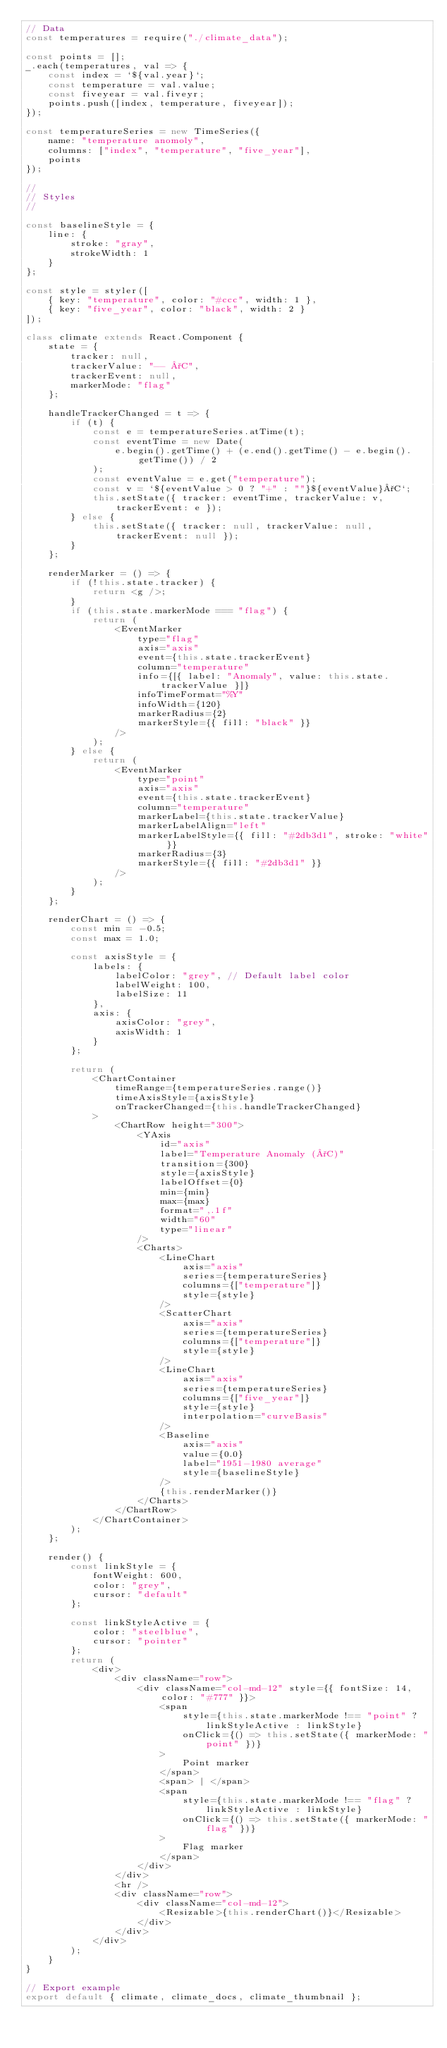Convert code to text. <code><loc_0><loc_0><loc_500><loc_500><_JavaScript_>// Data
const temperatures = require("./climate_data");

const points = [];
_.each(temperatures, val => {
    const index = `${val.year}`;
    const temperature = val.value;
    const fiveyear = val.fiveyr;
    points.push([index, temperature, fiveyear]);
});

const temperatureSeries = new TimeSeries({
    name: "temperature anomoly",
    columns: ["index", "temperature", "five_year"],
    points
});

//
// Styles
//

const baselineStyle = {
    line: {
        stroke: "gray",
        strokeWidth: 1
    }
};

const style = styler([
    { key: "temperature", color: "#ccc", width: 1 },
    { key: "five_year", color: "black", width: 2 }
]);

class climate extends React.Component {
    state = {
        tracker: null,
        trackerValue: "-- °C",
        trackerEvent: null,
        markerMode: "flag"
    };

    handleTrackerChanged = t => {
        if (t) {
            const e = temperatureSeries.atTime(t);
            const eventTime = new Date(
                e.begin().getTime() + (e.end().getTime() - e.begin().getTime()) / 2
            );
            const eventValue = e.get("temperature");
            const v = `${eventValue > 0 ? "+" : ""}${eventValue}°C`;
            this.setState({ tracker: eventTime, trackerValue: v, trackerEvent: e });
        } else {
            this.setState({ tracker: null, trackerValue: null, trackerEvent: null });
        }
    };

    renderMarker = () => {
        if (!this.state.tracker) {
            return <g />;
        }
        if (this.state.markerMode === "flag") {
            return (
                <EventMarker
                    type="flag"
                    axis="axis"
                    event={this.state.trackerEvent}
                    column="temperature"
                    info={[{ label: "Anomaly", value: this.state.trackerValue }]}
                    infoTimeFormat="%Y"
                    infoWidth={120}
                    markerRadius={2}
                    markerStyle={{ fill: "black" }}
                />
            );
        } else {
            return (
                <EventMarker
                    type="point"
                    axis="axis"
                    event={this.state.trackerEvent}
                    column="temperature"
                    markerLabel={this.state.trackerValue}
                    markerLabelAlign="left"
                    markerLabelStyle={{ fill: "#2db3d1", stroke: "white" }}
                    markerRadius={3}
                    markerStyle={{ fill: "#2db3d1" }}
                />
            );
        }
    };

    renderChart = () => {
        const min = -0.5;
        const max = 1.0;

        const axisStyle = {
            labels: {
                labelColor: "grey", // Default label color
                labelWeight: 100,
                labelSize: 11
            },
            axis: {
                axisColor: "grey",
                axisWidth: 1
            }
        };

        return (
            <ChartContainer
                timeRange={temperatureSeries.range()}
                timeAxisStyle={axisStyle}
                onTrackerChanged={this.handleTrackerChanged}
            >
                <ChartRow height="300">
                    <YAxis
                        id="axis"
                        label="Temperature Anomaly (°C)"
                        transition={300}
                        style={axisStyle}
                        labelOffset={0}
                        min={min}
                        max={max}
                        format=",.1f"
                        width="60"
                        type="linear"
                    />
                    <Charts>
                        <LineChart
                            axis="axis"
                            series={temperatureSeries}
                            columns={["temperature"]}
                            style={style}
                        />
                        <ScatterChart
                            axis="axis"
                            series={temperatureSeries}
                            columns={["temperature"]}
                            style={style}
                        />
                        <LineChart
                            axis="axis"
                            series={temperatureSeries}
                            columns={["five_year"]}
                            style={style}
                            interpolation="curveBasis"
                        />
                        <Baseline
                            axis="axis"
                            value={0.0}
                            label="1951-1980 average"
                            style={baselineStyle}
                        />
                        {this.renderMarker()}
                    </Charts>
                </ChartRow>
            </ChartContainer>
        );
    };

    render() {
        const linkStyle = {
            fontWeight: 600,
            color: "grey",
            cursor: "default"
        };

        const linkStyleActive = {
            color: "steelblue",
            cursor: "pointer"
        };
        return (
            <div>
                <div className="row">
                    <div className="col-md-12" style={{ fontSize: 14, color: "#777" }}>
                        <span
                            style={this.state.markerMode !== "point" ? linkStyleActive : linkStyle}
                            onClick={() => this.setState({ markerMode: "point" })}
                        >
                            Point marker
                        </span>
                        <span> | </span>
                        <span
                            style={this.state.markerMode !== "flag" ? linkStyleActive : linkStyle}
                            onClick={() => this.setState({ markerMode: "flag" })}
                        >
                            Flag marker
                        </span>
                    </div>
                </div>
                <hr />
                <div className="row">
                    <div className="col-md-12">
                        <Resizable>{this.renderChart()}</Resizable>
                    </div>
                </div>
            </div>
        );
    }
}

// Export example
export default { climate, climate_docs, climate_thumbnail };
</code> 